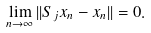Convert formula to latex. <formula><loc_0><loc_0><loc_500><loc_500>\lim _ { n \to \infty } | | S _ { j } x _ { n } - x _ { n } | | = 0 .</formula> 